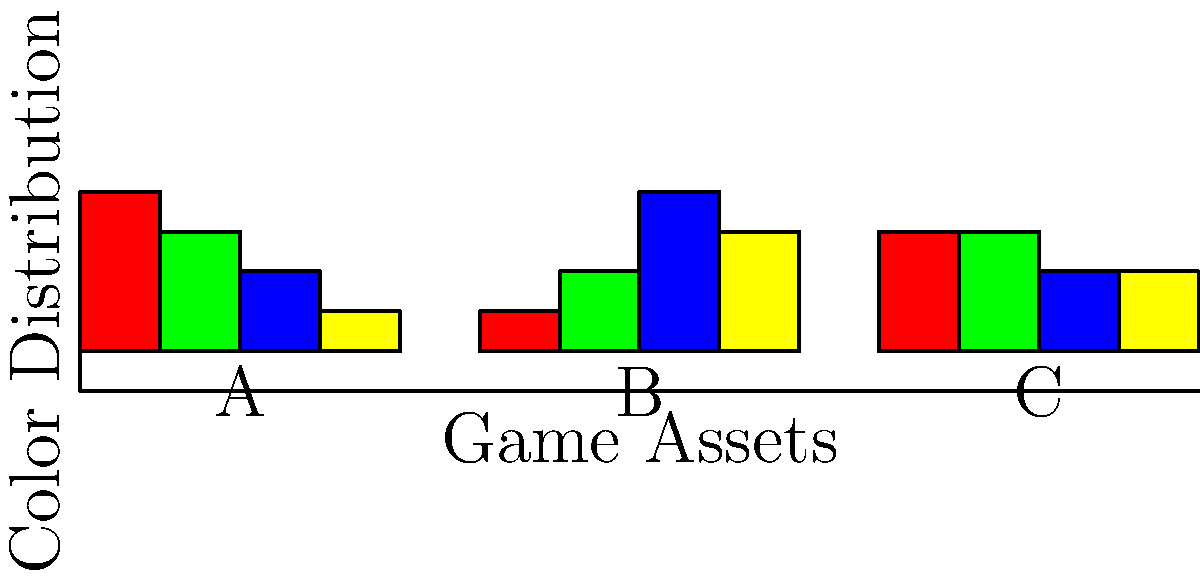In a game development project, you're tasked with categorizing game assets based on their color palette histograms. Given the histograms for three game assets (A, B, and C) shown above, which asset would be most suitable for a forest environment? Consider that forest environments typically have a higher proportion of green and brown colors. To determine which asset is most suitable for a forest environment, we need to analyze the color distributions in each histogram:

1. Understand the color representation:
   - Red bar represents warm colors (e.g., red, orange)
   - Green bar represents green colors
   - Blue bar represents cool colors (e.g., blue, purple)
   - Yellow bar represents neutral colors (e.g., brown, beige)

2. Analyze each asset:
   Asset A:
   - Highest proportion of red (40%)
   - Second-highest proportion of green (30%)
   - Lower proportions of blue and yellow

   Asset B:
   - Highest proportion of blue (40%)
   - Second-highest proportion of yellow (30%)
   - Lower proportions of red and green

   Asset C:
   - Equal highest proportions of red and green (30% each)
   - Equal lower proportions of blue and yellow (20% each)

3. Consider forest environment characteristics:
   - Forests typically have a higher proportion of green (foliage) and brown (tree trunks, earth) colors
   - In our color representation, green is directly represented, while brown would fall under the yellow (neutral) category

4. Compare assets for forest suitability:
   - Asset A has a high proportion of green but low yellow (brown), and too much red
   - Asset B has low green and high blue, which is not typical for forests
   - Asset C has the highest combined proportion of green and yellow (neutral/brown) colors (50%)

5. Conclusion:
   Asset C provides the best balance of colors suitable for a forest environment, with equal proportions of green and red (which can represent some warmer forest tones) and a significant amount of neutral colors that can represent brown elements.
Answer: Asset C 